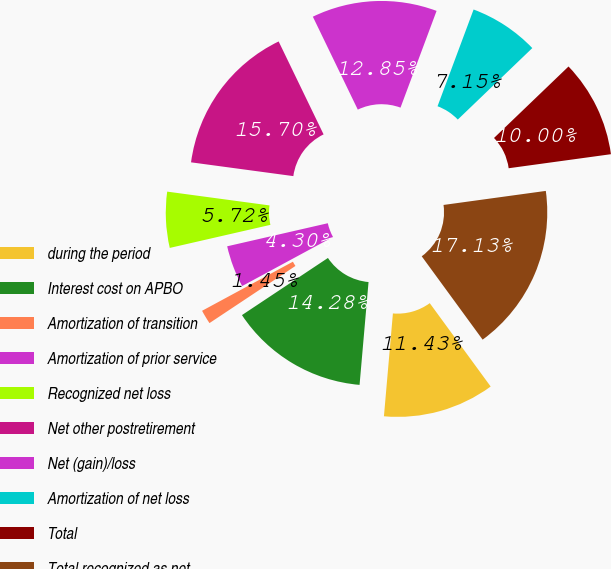<chart> <loc_0><loc_0><loc_500><loc_500><pie_chart><fcel>during the period<fcel>Interest cost on APBO<fcel>Amortization of transition<fcel>Amortization of prior service<fcel>Recognized net loss<fcel>Net other postretirement<fcel>Net (gain)/loss<fcel>Amortization of net loss<fcel>Total<fcel>Total recognized as net<nl><fcel>11.43%<fcel>14.28%<fcel>1.45%<fcel>4.3%<fcel>5.72%<fcel>15.7%<fcel>12.85%<fcel>7.15%<fcel>10.0%<fcel>17.13%<nl></chart> 